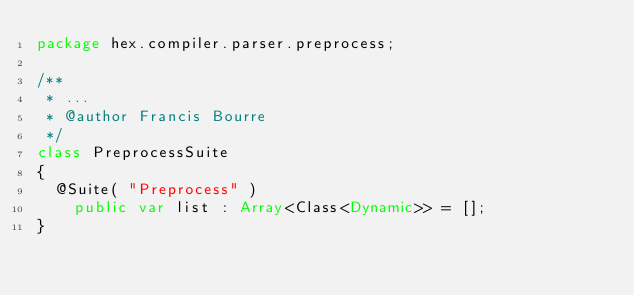Convert code to text. <code><loc_0><loc_0><loc_500><loc_500><_Haxe_>package hex.compiler.parser.preprocess;

/**
 * ...
 * @author Francis Bourre
 */
class PreprocessSuite
{
	@Suite( "Preprocess" )
    public var list : Array<Class<Dynamic>> = [];
}</code> 